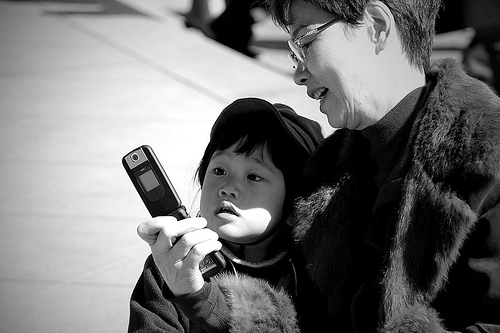How many people are there? There are two people in the image, an adult and a child, who appear to be focused on something they are viewing on a handheld device. 